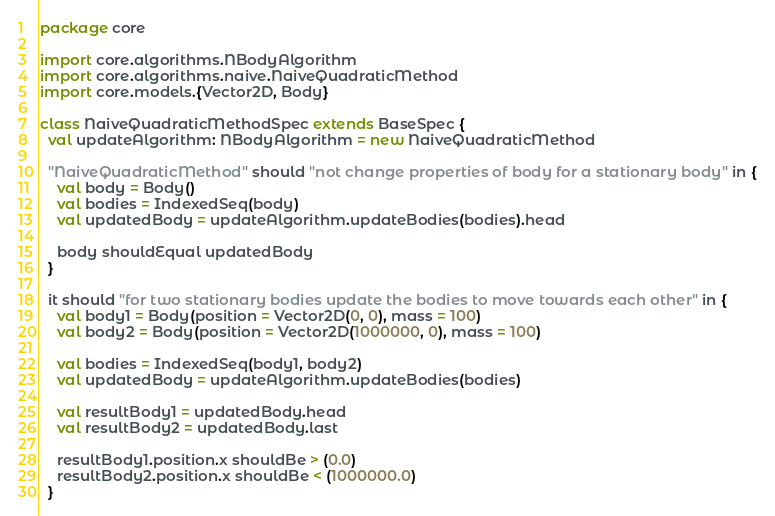<code> <loc_0><loc_0><loc_500><loc_500><_Scala_>package core

import core.algorithms.NBodyAlgorithm
import core.algorithms.naive.NaiveQuadraticMethod
import core.models.{Vector2D, Body}

class NaiveQuadraticMethodSpec extends BaseSpec {
  val updateAlgorithm: NBodyAlgorithm = new NaiveQuadraticMethod

  "NaiveQuadraticMethod" should "not change properties of body for a stationary body" in {
    val body = Body()
    val bodies = IndexedSeq(body)
    val updatedBody = updateAlgorithm.updateBodies(bodies).head

    body shouldEqual updatedBody
  }

  it should "for two stationary bodies update the bodies to move towards each other" in {
    val body1 = Body(position = Vector2D(0, 0), mass = 100)
    val body2 = Body(position = Vector2D(1000000, 0), mass = 100)

    val bodies = IndexedSeq(body1, body2)
    val updatedBody = updateAlgorithm.updateBodies(bodies)

    val resultBody1 = updatedBody.head
    val resultBody2 = updatedBody.last

    resultBody1.position.x shouldBe > (0.0)
    resultBody2.position.x shouldBe < (1000000.0)
  }
</code> 